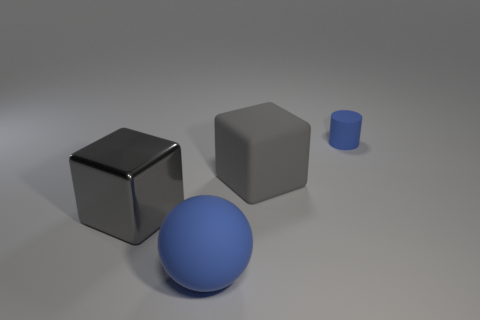Add 3 big red metallic objects. How many objects exist? 7 Subtract all balls. How many objects are left? 3 Add 1 blue rubber cylinders. How many blue rubber cylinders are left? 2 Add 1 tiny green rubber objects. How many tiny green rubber objects exist? 1 Subtract 0 gray balls. How many objects are left? 4 Subtract all big balls. Subtract all large gray metallic objects. How many objects are left? 2 